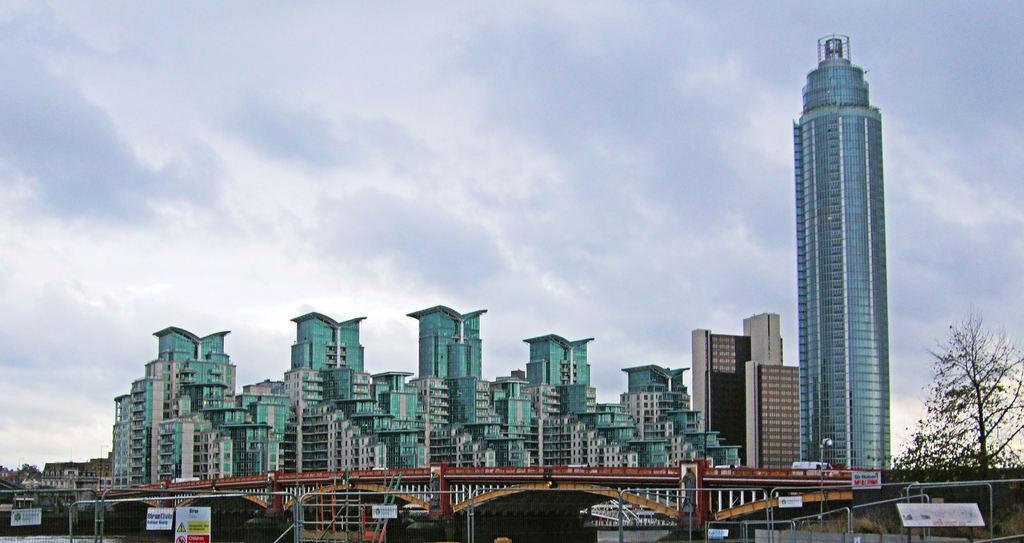Describe this image in one or two sentences. In this picture, we can see a few buildings with windows, trees, poles, metallic objects, bridge, poster with text and images on it, we can see the sky with clouds. 